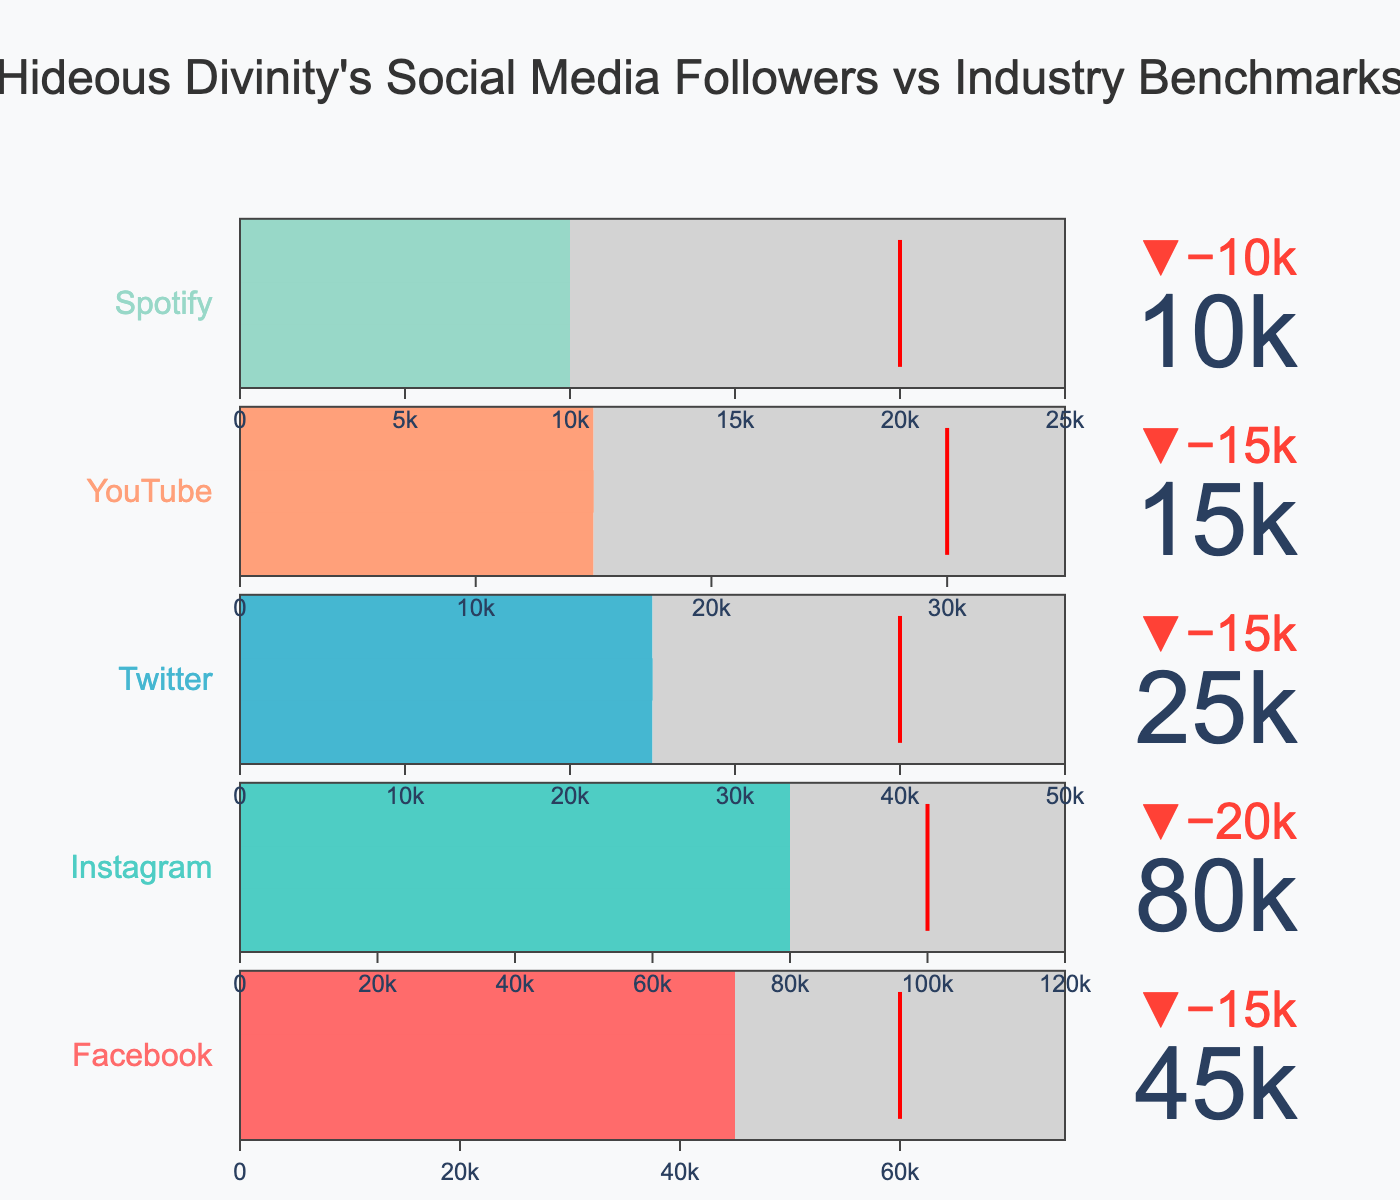What is the title of the figure? The title is prominently displayed at the top of the figure.
Answer: Hideous Divinity's Social Media Followers vs Industry Benchmarks How many social media platforms are compared in the figure? The figure lists social media platforms vertically, with each platform having its own section. By counting these sections, we can determine the number of platforms.
Answer: 5 Which social media platform has the highest number of followers? By observing the values for each platform, the highest number of followers is indicated by the leading bullet gauge value.
Answer: Instagram What is the difference between Hideous Divinity's Facebook followers and the industry benchmark? We subtract the benchmark value for Facebook from Hideous Divinity's followers on Facebook. The benchmark is 60,000 and the followers are 45,000.
Answer: 15,000 less Which platform has the smallest gap between followers and the target? For each platform, calculate the difference between its followers and target, then identify the smallest gap.
Answer: Facebook (30,000) Are Hideous Divinity's YouTube followers above, below, or at the benchmark? Compare the number of YouTube followers (15,000) to the YouTube benchmark (30,000) to determine their relative position.
Answer: Below What percentage of the Instagram target has been achieved by Hideous Divinity? Divide the Instagram followers (80,000) by the Instagram target (120,000) and multiply by 100 to get the percentage.
Answer: 66.67% Which social media platform is performing closest to its benchmark? Compare each platform's number of followers with its benchmark and identify the smallest difference.
Answer: Instagram What is the total number of followers across all platforms? Add the number of followers from each platform: 45,000 (Facebook) + 80,000 (Instagram) + 25,000 (Twitter) + 15,000 (YouTube) + 10,000 (Spotify).
Answer: 175,000 Where is the red threshold line located on the gauge of each platform, and what does it represent? The red threshold line is placed at the benchmark value for each platform. It represents the industry benchmark against which Hideous Divinity's followers are compared.
Answer: At the benchmark values (Facebook: 60,000, Instagram: 100,000, Twitter: 40,000, YouTube: 30,000, Spotify: 20,000) 